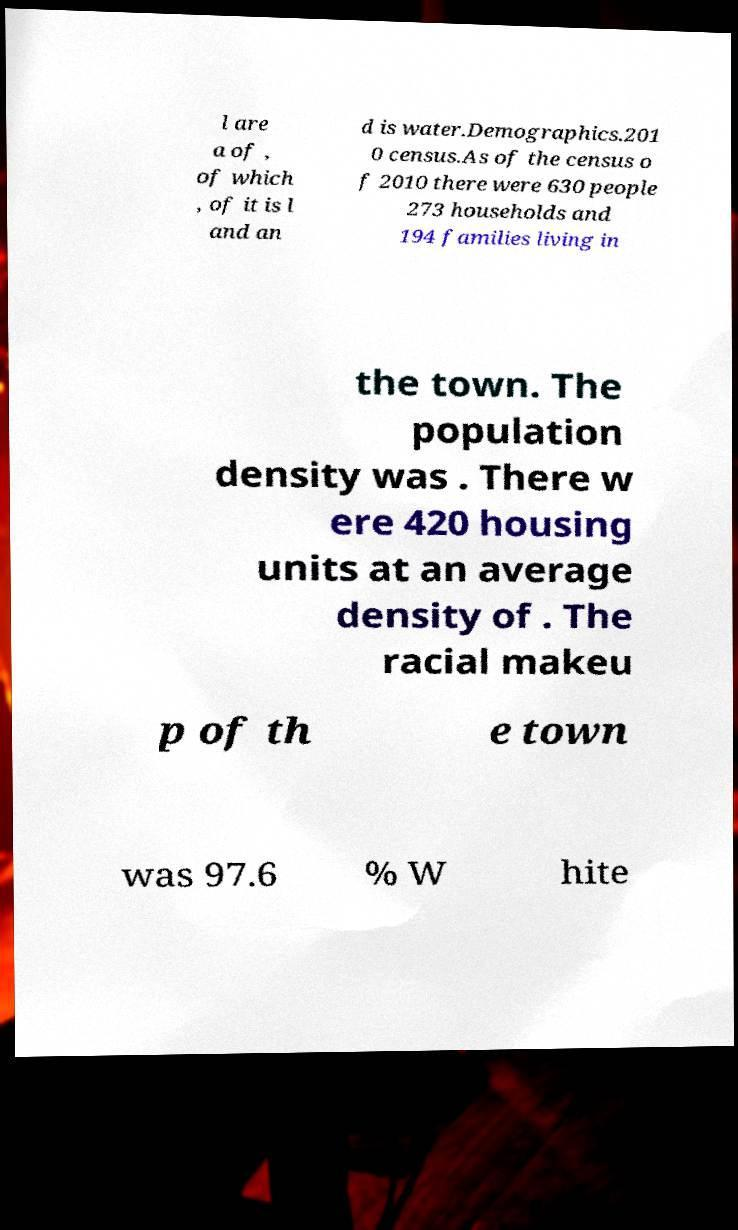There's text embedded in this image that I need extracted. Can you transcribe it verbatim? l are a of , of which , of it is l and an d is water.Demographics.201 0 census.As of the census o f 2010 there were 630 people 273 households and 194 families living in the town. The population density was . There w ere 420 housing units at an average density of . The racial makeu p of th e town was 97.6 % W hite 